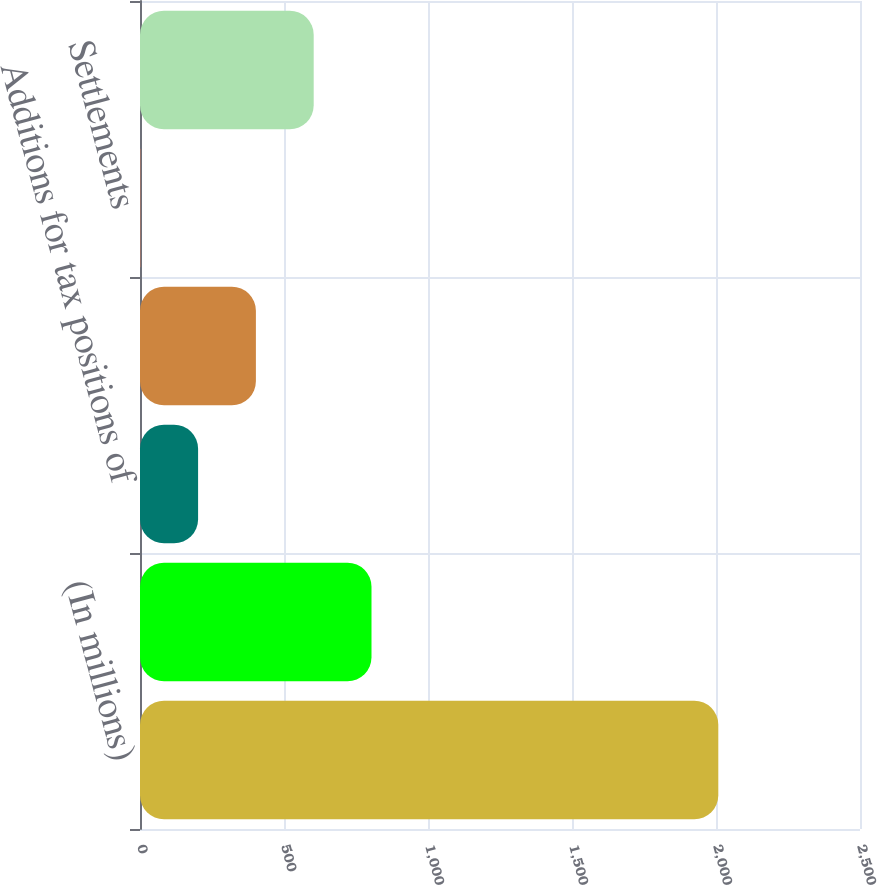<chart> <loc_0><loc_0><loc_500><loc_500><bar_chart><fcel>(In millions)<fcel>January 1 balance<fcel>Additions for tax positions of<fcel>Reductions for tax positions<fcel>Settlements<fcel>December 31 balance<nl><fcel>2008<fcel>803.8<fcel>201.7<fcel>402.4<fcel>1<fcel>603.1<nl></chart> 